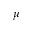<formula> <loc_0><loc_0><loc_500><loc_500>\mu</formula> 